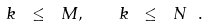Convert formula to latex. <formula><loc_0><loc_0><loc_500><loc_500>k \ \leq \ M , \quad k \ \leq \ N \ .</formula> 